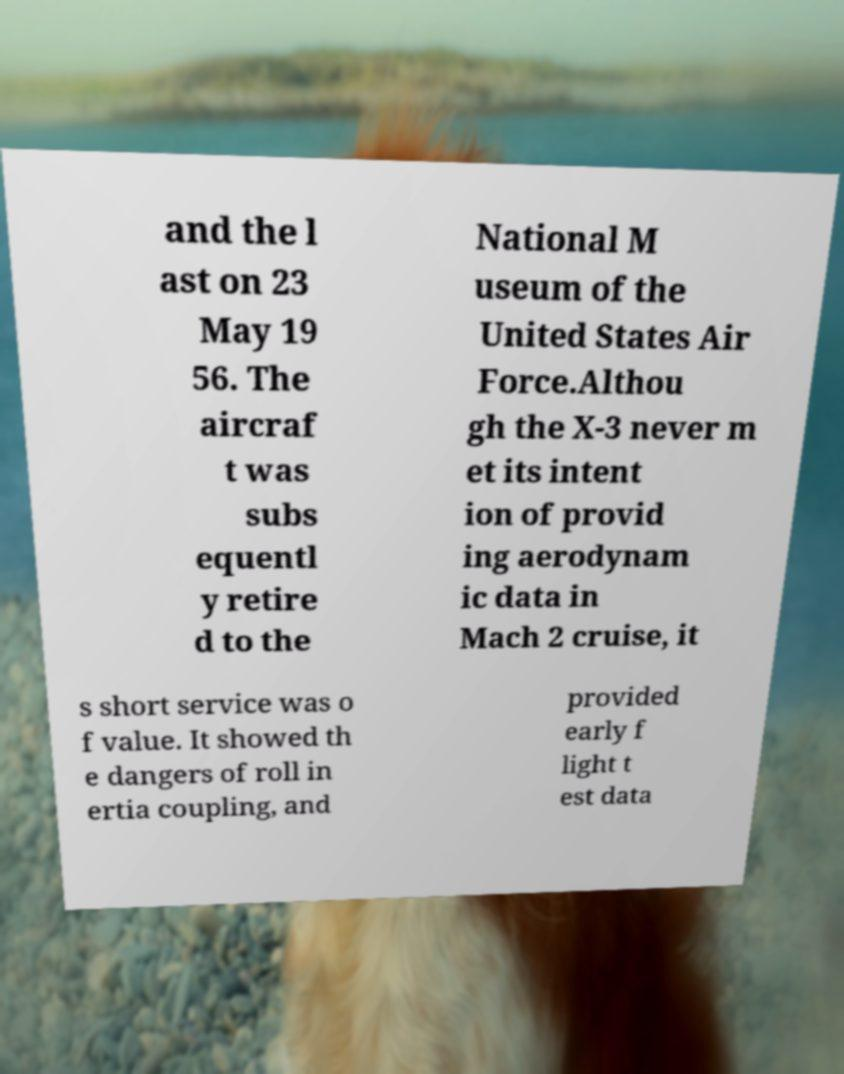Please read and relay the text visible in this image. What does it say? and the l ast on 23 May 19 56. The aircraf t was subs equentl y retire d to the National M useum of the United States Air Force.Althou gh the X-3 never m et its intent ion of provid ing aerodynam ic data in Mach 2 cruise, it s short service was o f value. It showed th e dangers of roll in ertia coupling, and provided early f light t est data 